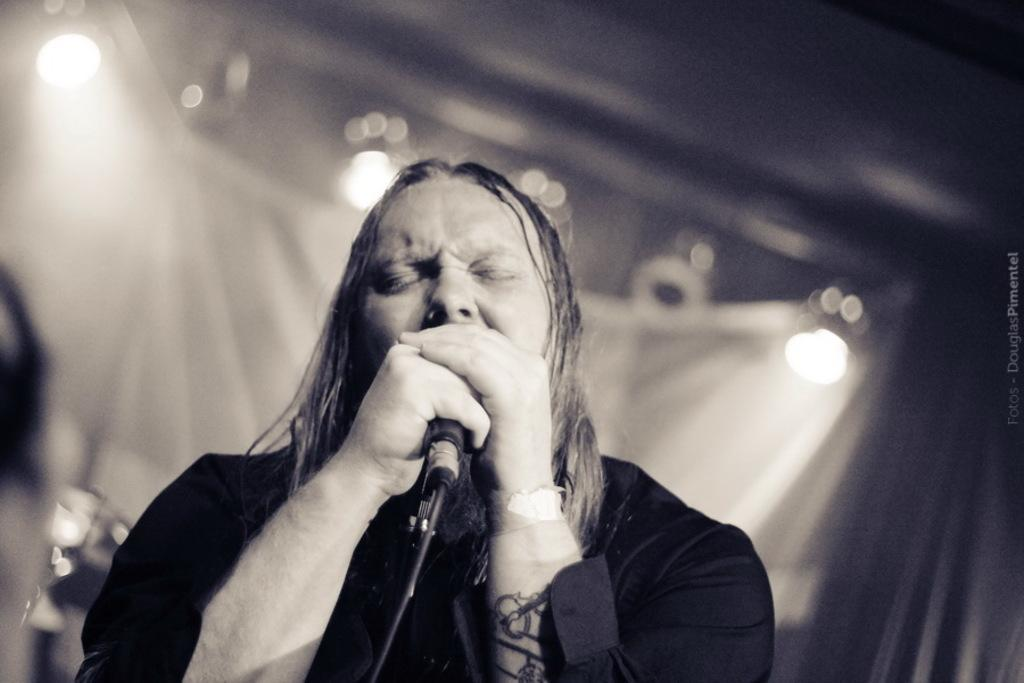Who is present in the image? There is a person in the image. What is the person doing in the image? The person is signing. What object is the person holding in the image? The person is holding a microphone. What can be seen in the background of the image? There are lights visible in the background of the image. What type of knot is the person tying in the image? There is no knot present in the image; the person is signing and holding a microphone. 